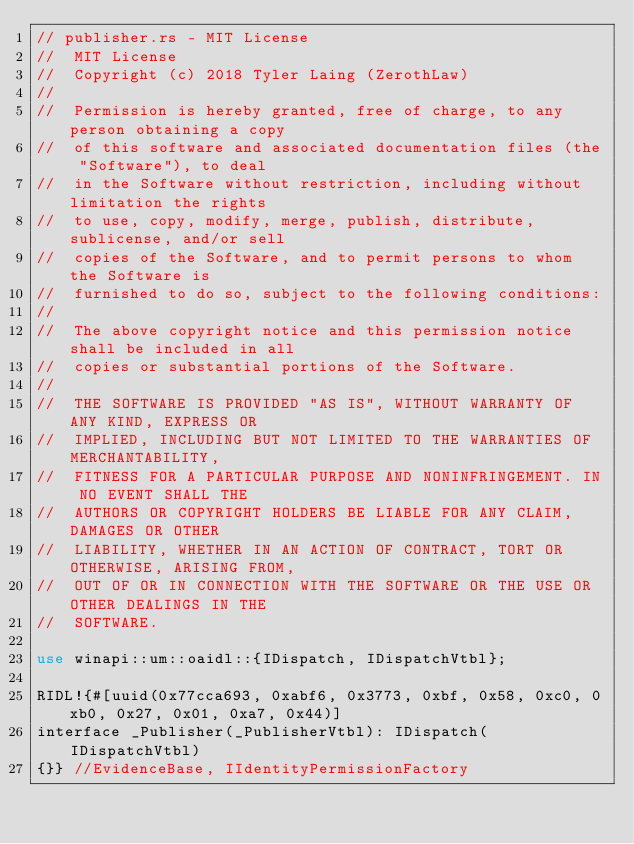<code> <loc_0><loc_0><loc_500><loc_500><_Rust_>// publisher.rs - MIT License
//  MIT License
//  Copyright (c) 2018 Tyler Laing (ZerothLaw)
// 
//  Permission is hereby granted, free of charge, to any person obtaining a copy
//  of this software and associated documentation files (the "Software"), to deal
//  in the Software without restriction, including without limitation the rights
//  to use, copy, modify, merge, publish, distribute, sublicense, and/or sell
//  copies of the Software, and to permit persons to whom the Software is
//  furnished to do so, subject to the following conditions:
// 
//  The above copyright notice and this permission notice shall be included in all
//  copies or substantial portions of the Software.
// 
//  THE SOFTWARE IS PROVIDED "AS IS", WITHOUT WARRANTY OF ANY KIND, EXPRESS OR
//  IMPLIED, INCLUDING BUT NOT LIMITED TO THE WARRANTIES OF MERCHANTABILITY,
//  FITNESS FOR A PARTICULAR PURPOSE AND NONINFRINGEMENT. IN NO EVENT SHALL THE
//  AUTHORS OR COPYRIGHT HOLDERS BE LIABLE FOR ANY CLAIM, DAMAGES OR OTHER
//  LIABILITY, WHETHER IN AN ACTION OF CONTRACT, TORT OR OTHERWISE, ARISING FROM,
//  OUT OF OR IN CONNECTION WITH THE SOFTWARE OR THE USE OR OTHER DEALINGS IN THE
//  SOFTWARE.

use winapi::um::oaidl::{IDispatch, IDispatchVtbl};

RIDL!{#[uuid(0x77cca693, 0xabf6, 0x3773, 0xbf, 0x58, 0xc0, 0xb0, 0x27, 0x01, 0xa7, 0x44)]
interface _Publisher(_PublisherVtbl): IDispatch(IDispatchVtbl)  
{}} //EvidenceBase, IIdentityPermissionFactory</code> 